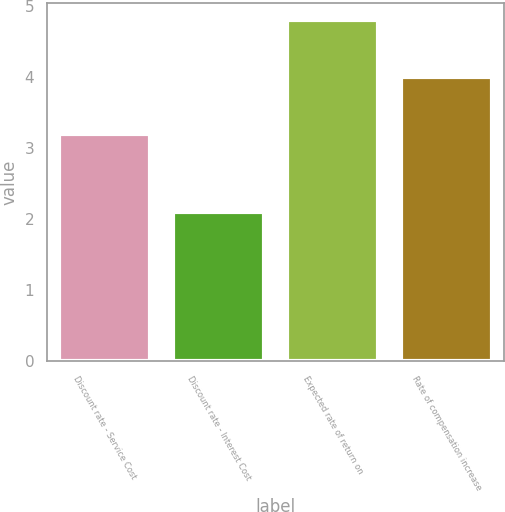<chart> <loc_0><loc_0><loc_500><loc_500><bar_chart><fcel>Discount rate - Service Cost<fcel>Discount rate - Interest Cost<fcel>Expected rate of return on<fcel>Rate of compensation increase<nl><fcel>3.2<fcel>2.1<fcel>4.8<fcel>4<nl></chart> 